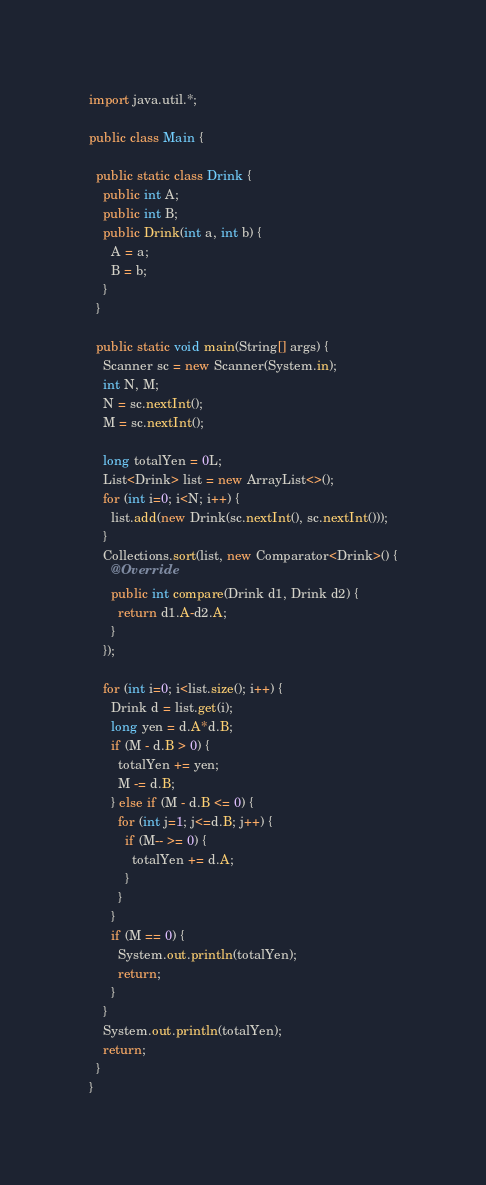<code> <loc_0><loc_0><loc_500><loc_500><_Java_>import java.util.*;

public class Main {
  
  public static class Drink {
    public int A;
    public int B;
    public Drink(int a, int b) {
      A = a;
      B = b;
    }
  }
  
  public static void main(String[] args) {
    Scanner sc = new Scanner(System.in);
    int N, M;
    N = sc.nextInt();
    M = sc.nextInt();
    
    long totalYen = 0L;
    List<Drink> list = new ArrayList<>();
    for (int i=0; i<N; i++) {
      list.add(new Drink(sc.nextInt(), sc.nextInt()));
    }
    Collections.sort(list, new Comparator<Drink>() {
      @Override
      public int compare(Drink d1, Drink d2) {
        return d1.A-d2.A;
      }
    });
    
    for (int i=0; i<list.size(); i++) {
      Drink d = list.get(i);
      long yen = d.A*d.B;
      if (M - d.B > 0) {
        totalYen += yen;
        M -= d.B;
      } else if (M - d.B <= 0) {
        for (int j=1; j<=d.B; j++) {
          if (M-- >= 0) {
          	totalYen += d.A;
          }
        }
      }
      if (M == 0) {
        System.out.println(totalYen);
        return;
      } 
    }
    System.out.println(totalYen);
    return;
  }
}
</code> 